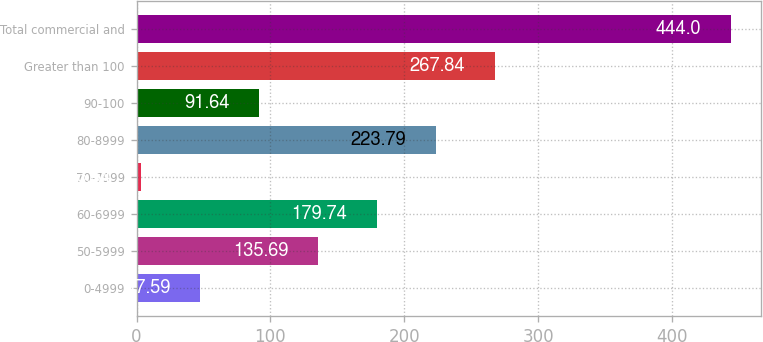<chart> <loc_0><loc_0><loc_500><loc_500><bar_chart><fcel>0-4999<fcel>50-5999<fcel>60-6999<fcel>70-7999<fcel>80-8999<fcel>90-100<fcel>Greater than 100<fcel>Total commercial and<nl><fcel>47.59<fcel>135.69<fcel>179.74<fcel>3.54<fcel>223.79<fcel>91.64<fcel>267.84<fcel>444<nl></chart> 